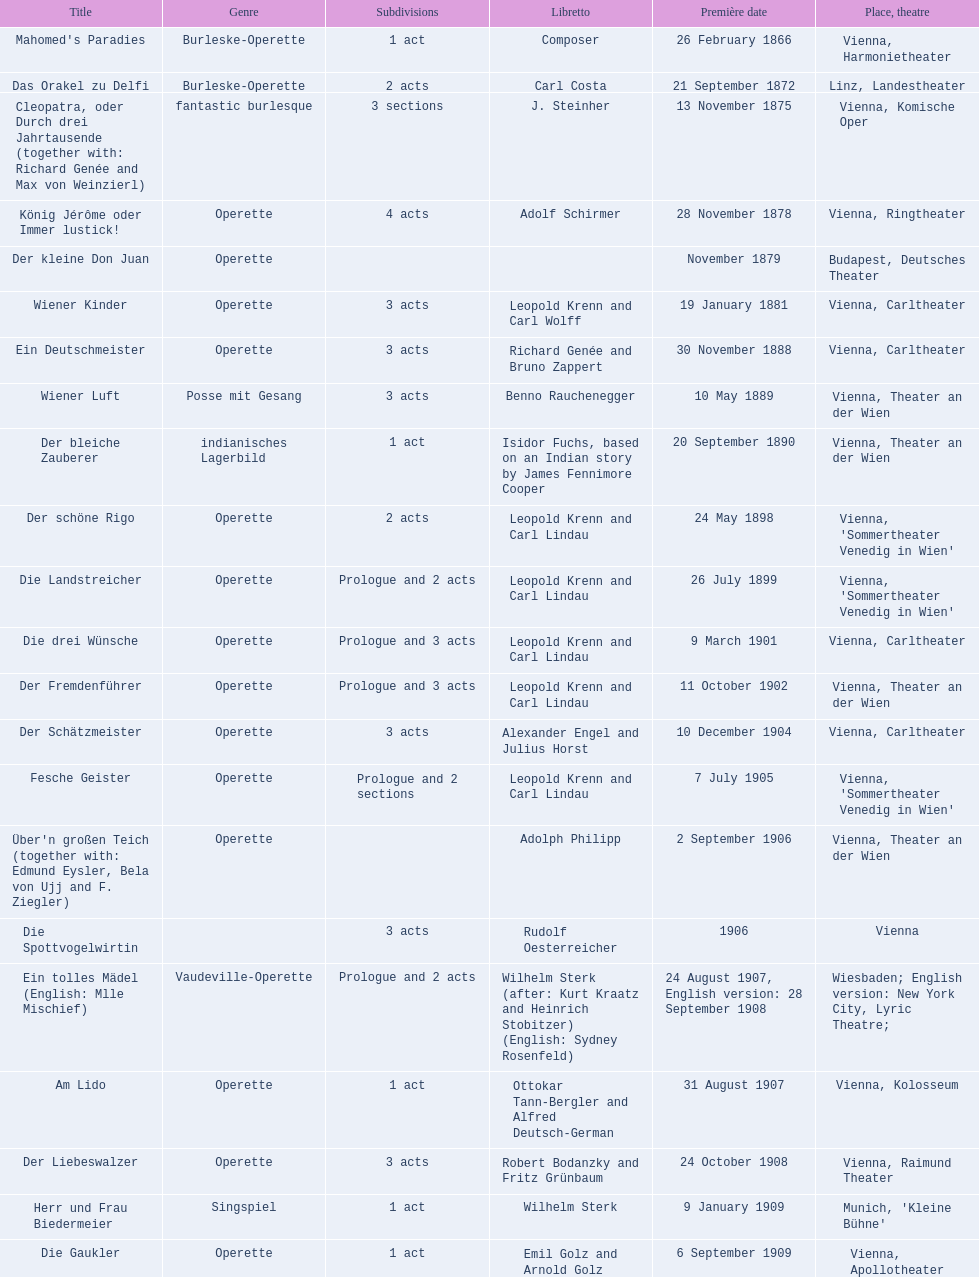What was the year of the last title? 1958. 